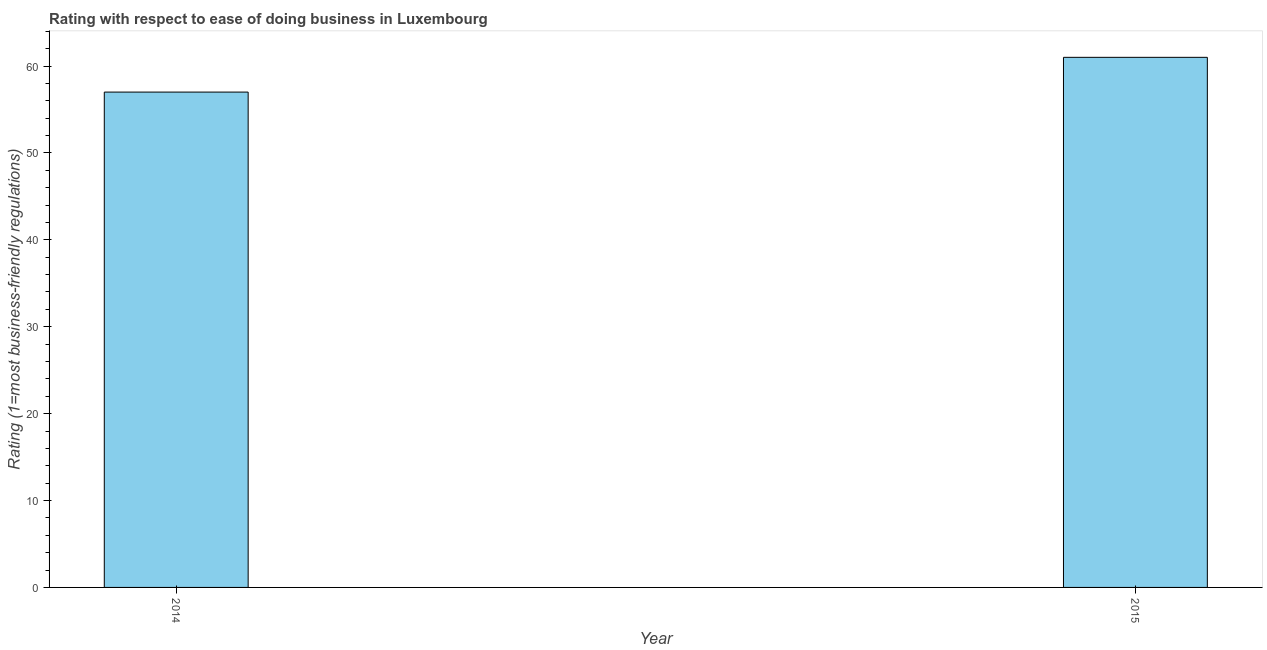What is the title of the graph?
Make the answer very short. Rating with respect to ease of doing business in Luxembourg. What is the label or title of the Y-axis?
Ensure brevity in your answer.  Rating (1=most business-friendly regulations). What is the ease of doing business index in 2014?
Offer a very short reply. 57. Across all years, what is the maximum ease of doing business index?
Your answer should be compact. 61. Across all years, what is the minimum ease of doing business index?
Make the answer very short. 57. In which year was the ease of doing business index maximum?
Provide a short and direct response. 2015. In which year was the ease of doing business index minimum?
Your answer should be very brief. 2014. What is the sum of the ease of doing business index?
Your response must be concise. 118. What is the difference between the ease of doing business index in 2014 and 2015?
Your answer should be compact. -4. What is the median ease of doing business index?
Ensure brevity in your answer.  59. Do a majority of the years between 2015 and 2014 (inclusive) have ease of doing business index greater than 18 ?
Ensure brevity in your answer.  No. What is the ratio of the ease of doing business index in 2014 to that in 2015?
Your answer should be compact. 0.93. How many bars are there?
Provide a succinct answer. 2. What is the difference between two consecutive major ticks on the Y-axis?
Your response must be concise. 10. Are the values on the major ticks of Y-axis written in scientific E-notation?
Provide a succinct answer. No. What is the Rating (1=most business-friendly regulations) of 2015?
Offer a terse response. 61. What is the difference between the Rating (1=most business-friendly regulations) in 2014 and 2015?
Offer a very short reply. -4. What is the ratio of the Rating (1=most business-friendly regulations) in 2014 to that in 2015?
Your answer should be compact. 0.93. 